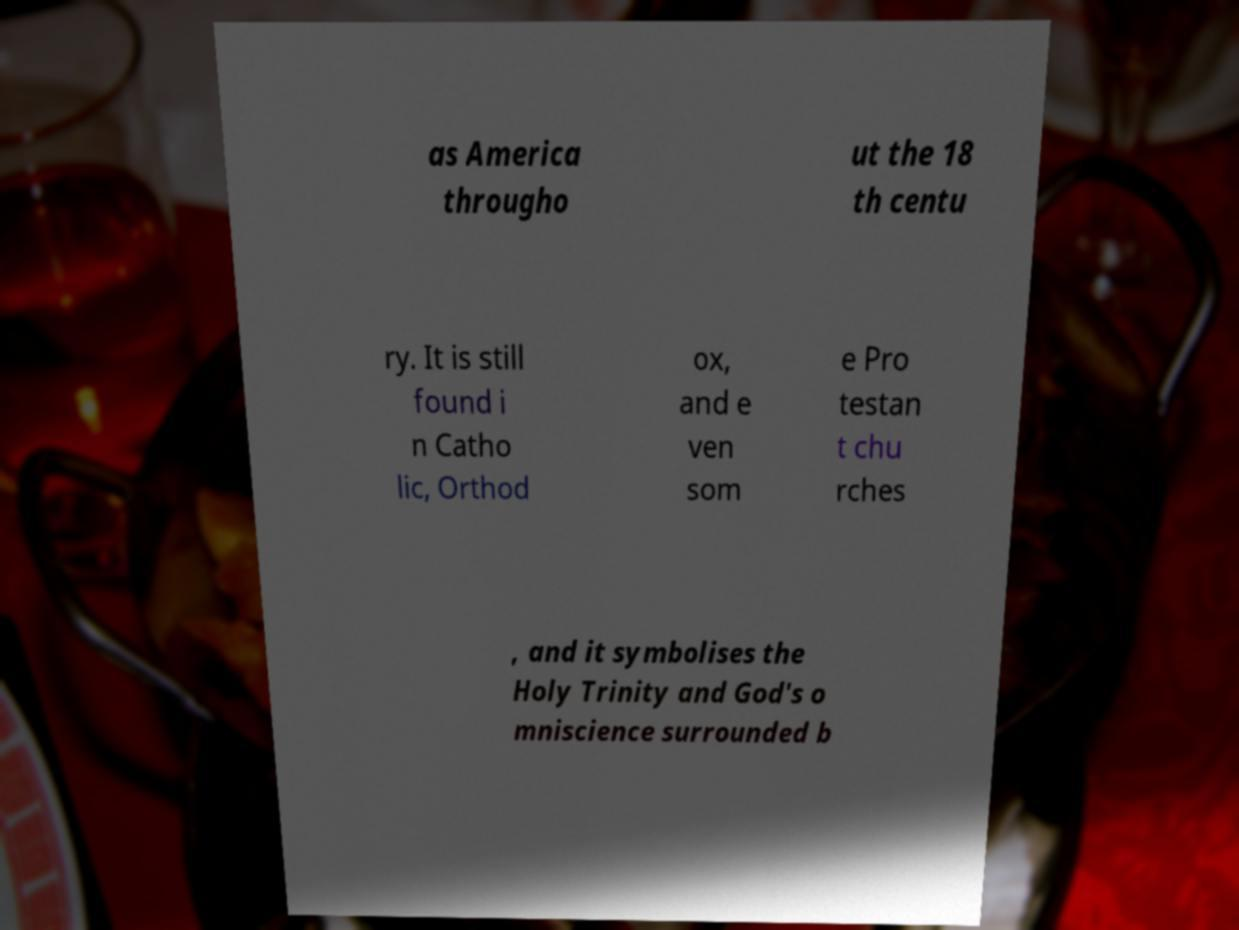Can you read and provide the text displayed in the image?This photo seems to have some interesting text. Can you extract and type it out for me? as America througho ut the 18 th centu ry. It is still found i n Catho lic, Orthod ox, and e ven som e Pro testan t chu rches , and it symbolises the Holy Trinity and God's o mniscience surrounded b 